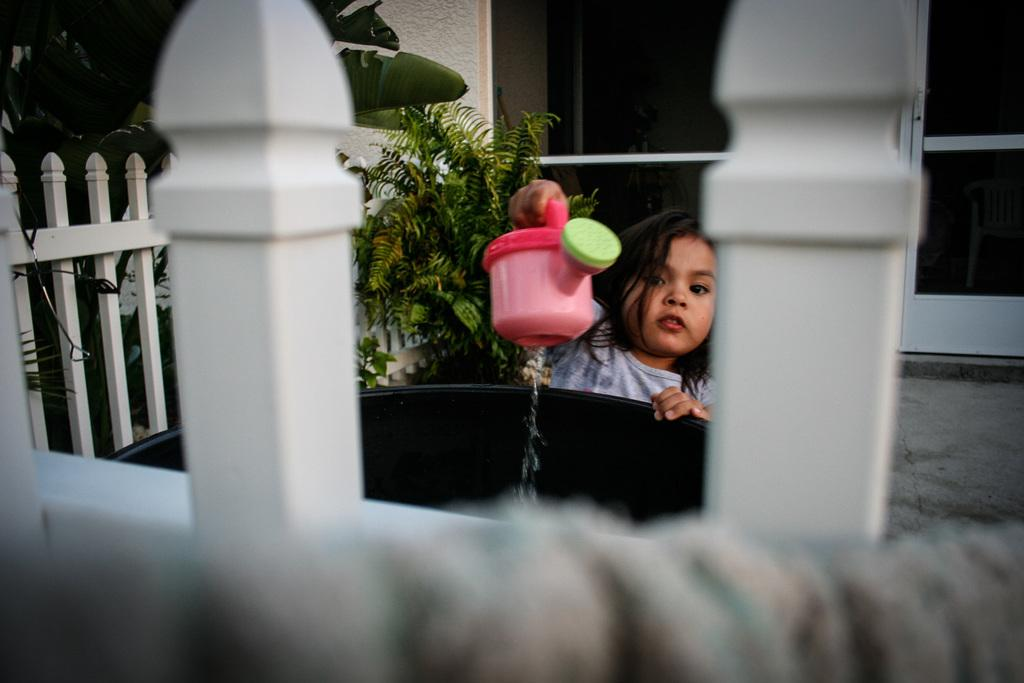Who is present in the image? There is a girl in the image. What is the girl doing in the image? The girl is standing beside a container and holding a watering can. What can be seen in the background of the image? There is a fence, plants, a wall, and a door in the image. What type of country is depicted in the image? There is no country depicted in the image; it features a girl, a container, a watering can, and various background elements. What is the mass of the girl in the image? The mass of the girl cannot be determined from the image. 